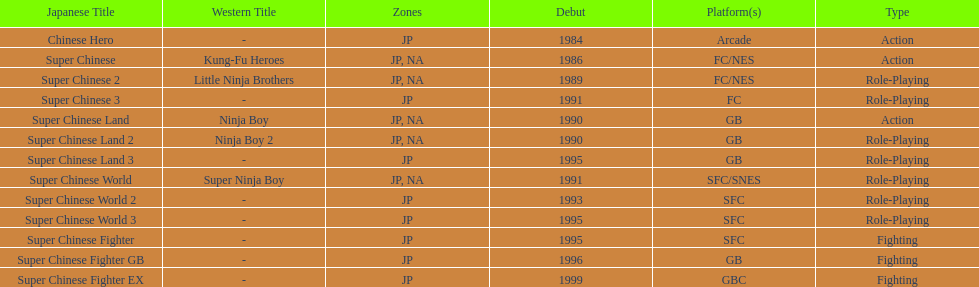Number of super chinese world games released 3. Give me the full table as a dictionary. {'header': ['Japanese Title', 'Western Title', 'Zones', 'Debut', 'Platform(s)', 'Type'], 'rows': [['Chinese Hero', '-', 'JP', '1984', 'Arcade', 'Action'], ['Super Chinese', 'Kung-Fu Heroes', 'JP, NA', '1986', 'FC/NES', 'Action'], ['Super Chinese 2', 'Little Ninja Brothers', 'JP, NA', '1989', 'FC/NES', 'Role-Playing'], ['Super Chinese 3', '-', 'JP', '1991', 'FC', 'Role-Playing'], ['Super Chinese Land', 'Ninja Boy', 'JP, NA', '1990', 'GB', 'Action'], ['Super Chinese Land 2', 'Ninja Boy 2', 'JP, NA', '1990', 'GB', 'Role-Playing'], ['Super Chinese Land 3', '-', 'JP', '1995', 'GB', 'Role-Playing'], ['Super Chinese World', 'Super Ninja Boy', 'JP, NA', '1991', 'SFC/SNES', 'Role-Playing'], ['Super Chinese World 2', '-', 'JP', '1993', 'SFC', 'Role-Playing'], ['Super Chinese World 3', '-', 'JP', '1995', 'SFC', 'Role-Playing'], ['Super Chinese Fighter', '-', 'JP', '1995', 'SFC', 'Fighting'], ['Super Chinese Fighter GB', '-', 'JP', '1996', 'GB', 'Fighting'], ['Super Chinese Fighter EX', '-', 'JP', '1999', 'GBC', 'Fighting']]} 